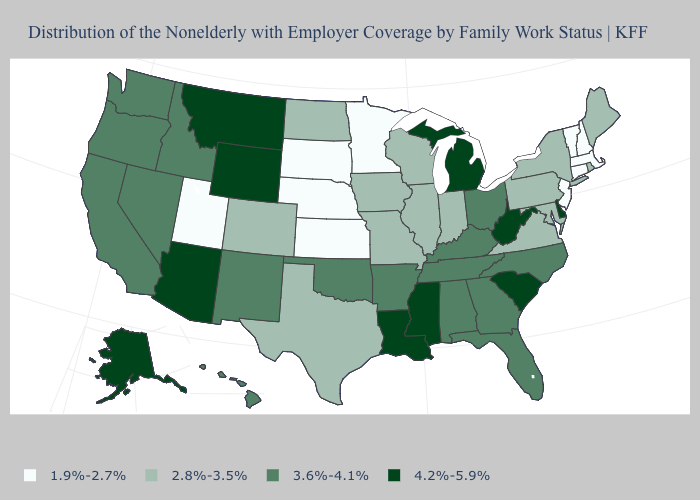Is the legend a continuous bar?
Short answer required. No. Name the states that have a value in the range 4.2%-5.9%?
Short answer required. Alaska, Arizona, Delaware, Louisiana, Michigan, Mississippi, Montana, South Carolina, West Virginia, Wyoming. What is the value of Alabama?
Be succinct. 3.6%-4.1%. What is the value of Utah?
Short answer required. 1.9%-2.7%. What is the value of Wisconsin?
Write a very short answer. 2.8%-3.5%. Does Kentucky have the same value as North Carolina?
Give a very brief answer. Yes. Does Alabama have the highest value in the USA?
Keep it brief. No. What is the highest value in the USA?
Give a very brief answer. 4.2%-5.9%. What is the highest value in the USA?
Answer briefly. 4.2%-5.9%. Name the states that have a value in the range 2.8%-3.5%?
Give a very brief answer. Colorado, Illinois, Indiana, Iowa, Maine, Maryland, Missouri, New York, North Dakota, Pennsylvania, Rhode Island, Texas, Virginia, Wisconsin. Name the states that have a value in the range 1.9%-2.7%?
Be succinct. Connecticut, Kansas, Massachusetts, Minnesota, Nebraska, New Hampshire, New Jersey, South Dakota, Utah, Vermont. Name the states that have a value in the range 1.9%-2.7%?
Write a very short answer. Connecticut, Kansas, Massachusetts, Minnesota, Nebraska, New Hampshire, New Jersey, South Dakota, Utah, Vermont. Which states have the lowest value in the USA?
Give a very brief answer. Connecticut, Kansas, Massachusetts, Minnesota, Nebraska, New Hampshire, New Jersey, South Dakota, Utah, Vermont. Among the states that border Tennessee , does Missouri have the lowest value?
Quick response, please. Yes. Name the states that have a value in the range 2.8%-3.5%?
Be succinct. Colorado, Illinois, Indiana, Iowa, Maine, Maryland, Missouri, New York, North Dakota, Pennsylvania, Rhode Island, Texas, Virginia, Wisconsin. 